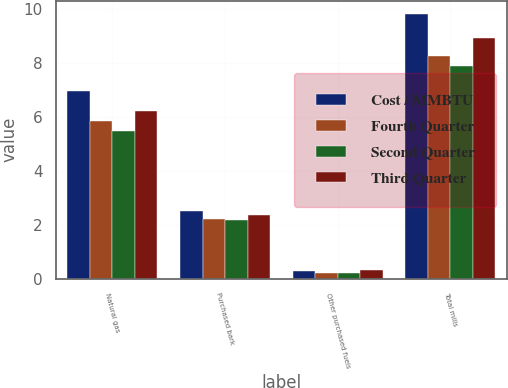Convert chart to OTSL. <chart><loc_0><loc_0><loc_500><loc_500><stacked_bar_chart><ecel><fcel>Natural gas<fcel>Purchased bark<fcel>Other purchased fuels<fcel>Total mills<nl><fcel>Cost / MMBTU<fcel>6.97<fcel>2.53<fcel>0.31<fcel>9.81<nl><fcel>Fourth Quarter<fcel>5.83<fcel>2.2<fcel>0.23<fcel>8.26<nl><fcel>Second Quarter<fcel>5.47<fcel>2.17<fcel>0.23<fcel>7.87<nl><fcel>Third Quarter<fcel>6.23<fcel>2.37<fcel>0.33<fcel>8.93<nl></chart> 